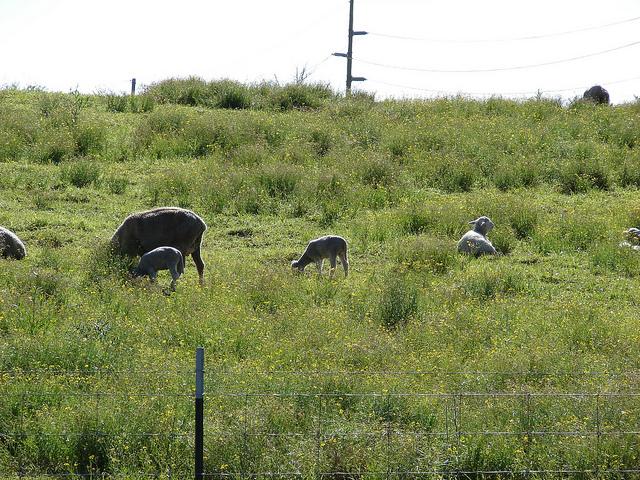Are these animals free to roam?
Keep it brief. Yes. What kind of animals are in the field?
Short answer required. Sheep. Are these animals in their natural environment?
Answer briefly. Yes. Are all the animals standing?
Concise answer only. No. Are the sheep likely to jump over the fence?
Concise answer only. No. Are those mountains in the background?
Be succinct. No. 